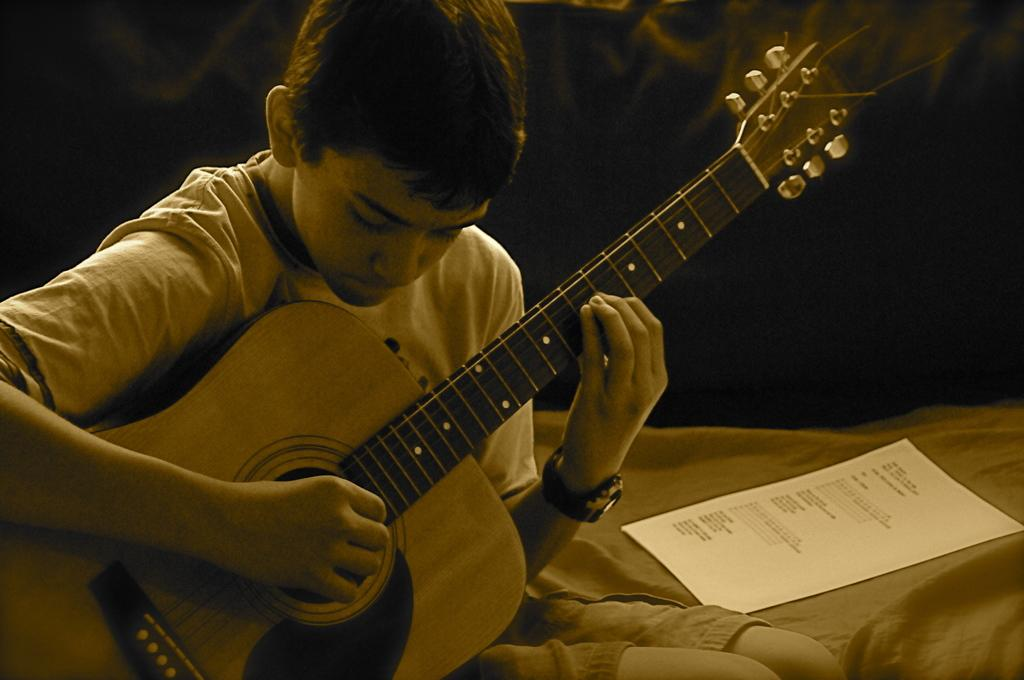What is the main subject of the image? The main subject of the image is a kid. What is the kid wearing in the image? The kid is wearing a T-shirt in the image. What activity is the kid engaged in? The kid is playing a guitar in the image. What can be seen on the right side of the image? There is a paper on the right side of the image. What type of beast can be seen attacking the guitar in the image? There is no beast present in the image, and the guitar is not being attacked. 